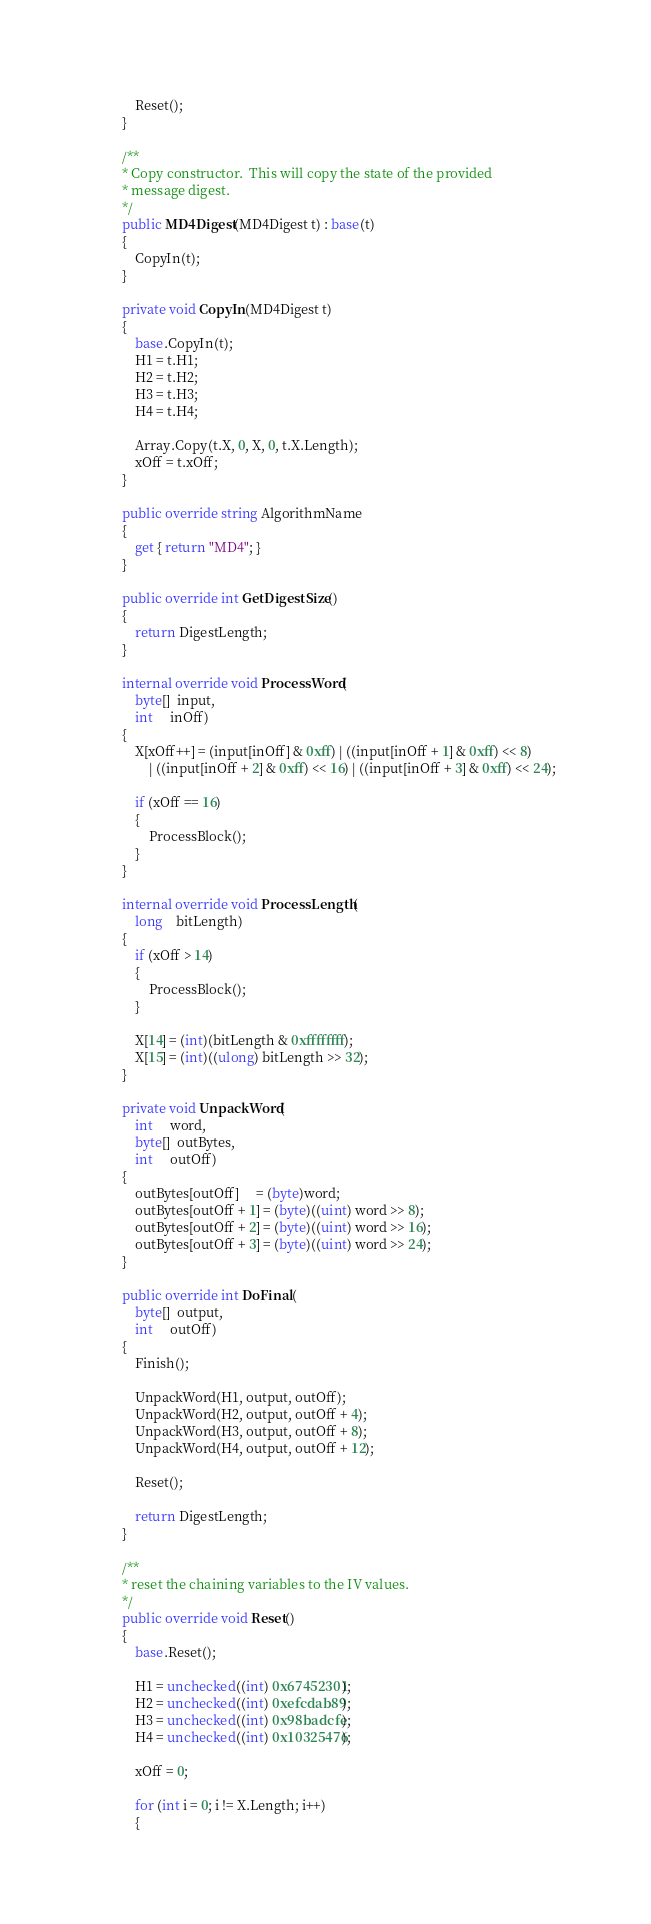<code> <loc_0><loc_0><loc_500><loc_500><_C#_>            Reset();
        }

        /**
        * Copy constructor.  This will copy the state of the provided
        * message digest.
        */
        public MD4Digest(MD4Digest t) : base(t)
		{
			CopyIn(t);
		}

		private void CopyIn(MD4Digest t)
		{
			base.CopyIn(t);
            H1 = t.H1;
            H2 = t.H2;
            H3 = t.H3;
            H4 = t.H4;

            Array.Copy(t.X, 0, X, 0, t.X.Length);
            xOff = t.xOff;
        }

		public override string AlgorithmName
		{
			get { return "MD4"; }
		}

		public override int GetDigestSize()
		{
			return DigestLength;
		}

		internal override void ProcessWord(
            byte[]  input,
            int     inOff)
        {
            X[xOff++] = (input[inOff] & 0xff) | ((input[inOff + 1] & 0xff) << 8)
                | ((input[inOff + 2] & 0xff) << 16) | ((input[inOff + 3] & 0xff) << 24);

            if (xOff == 16)
            {
                ProcessBlock();
            }
        }

        internal override void ProcessLength(
            long    bitLength)
        {
            if (xOff > 14)
            {
                ProcessBlock();
            }

            X[14] = (int)(bitLength & 0xffffffff);
            X[15] = (int)((ulong) bitLength >> 32);
        }

        private void UnpackWord(
            int     word,
            byte[]  outBytes,
            int     outOff)
        {
            outBytes[outOff]     = (byte)word;
            outBytes[outOff + 1] = (byte)((uint) word >> 8);
            outBytes[outOff + 2] = (byte)((uint) word >> 16);
            outBytes[outOff + 3] = (byte)((uint) word >> 24);
        }

        public override int DoFinal(
            byte[]  output,
            int     outOff)
        {
            Finish();

            UnpackWord(H1, output, outOff);
            UnpackWord(H2, output, outOff + 4);
            UnpackWord(H3, output, outOff + 8);
            UnpackWord(H4, output, outOff + 12);

            Reset();

            return DigestLength;
        }

        /**
        * reset the chaining variables to the IV values.
        */
        public override void Reset()
        {
            base.Reset();

            H1 = unchecked((int) 0x67452301);
            H2 = unchecked((int) 0xefcdab89);
            H3 = unchecked((int) 0x98badcfe);
            H4 = unchecked((int) 0x10325476);

            xOff = 0;

            for (int i = 0; i != X.Length; i++)
            {</code> 